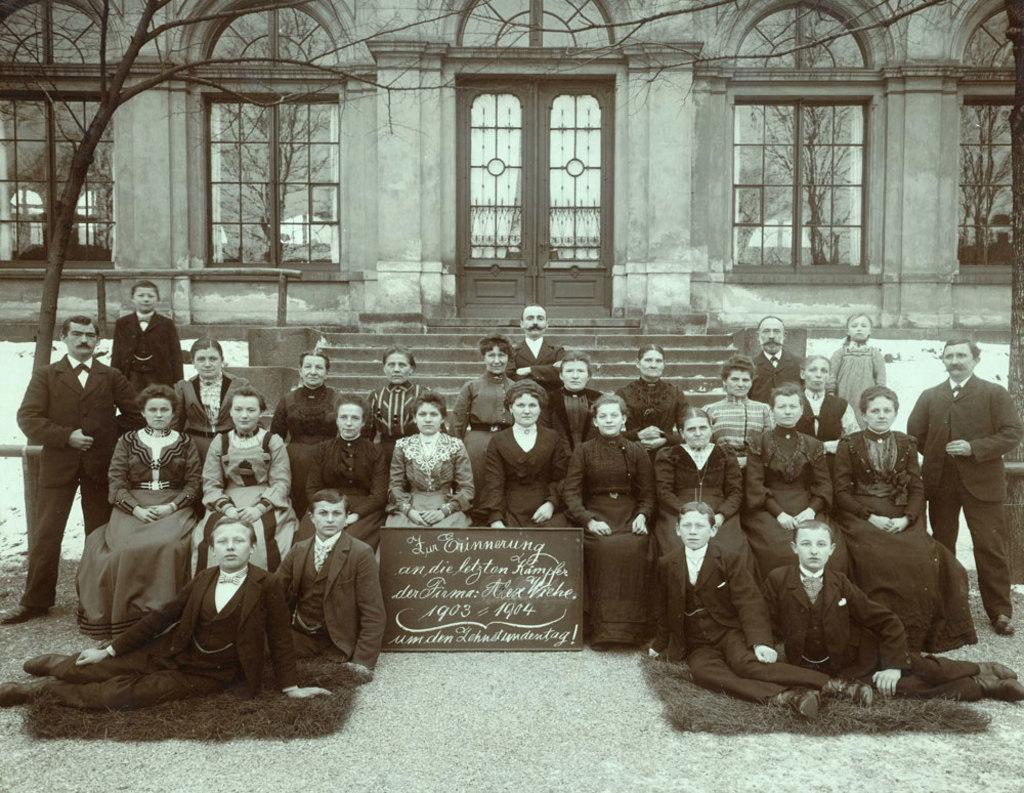How would you summarize this image in a sentence or two? This image is a black and white image. This image is taken outdoors. At the bottom of the image there is a ground. In the background there is a building with walls, doors and windows. There are a few stairs. There are a few trees. In the middle of the image a few people are sitting on the chairs and a few are standing. A few are sitting on the ground and there is a board with a text on it. 